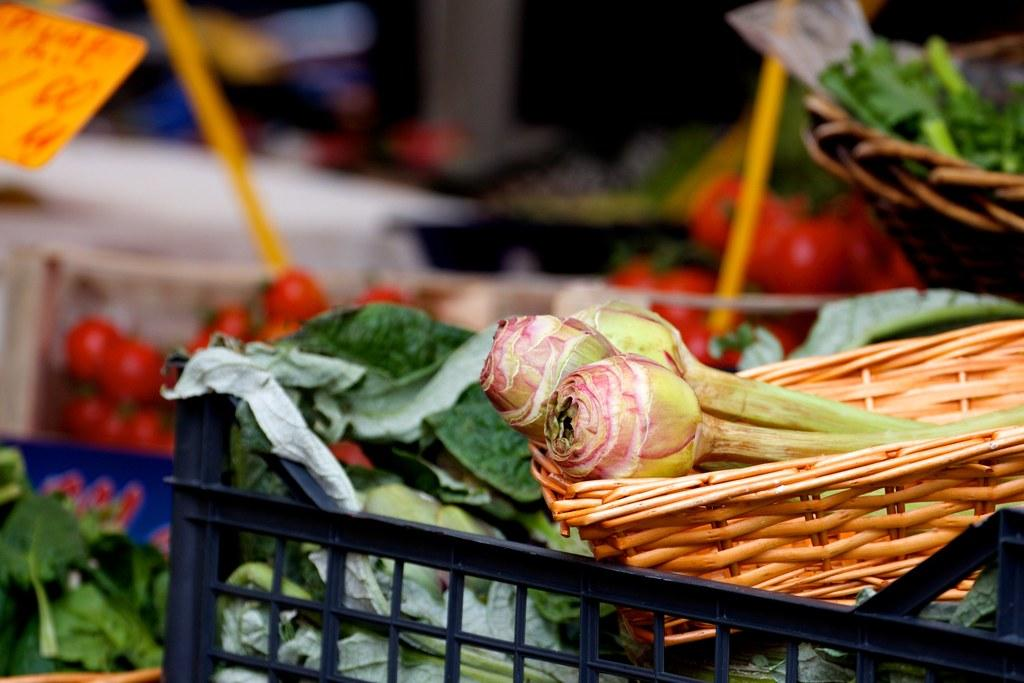What type of food items are present in the image? There are vegetables in the image. How are the vegetables organized in the image? The vegetables are arranged in baskets. Are there any identifiers for the vegetables in the image? Yes, there are labels associated with the baskets. Can you describe the background of the image? The background of the image is blurry. What type of engine can be seen powering the hand in the image? There is no engine or hand present in the image; it features vegetables arranged in baskets with labels. What brand of toothpaste is being advertised in the image? There is no toothpaste or advertisement present in the image; it features vegetables arranged in baskets with labels. 